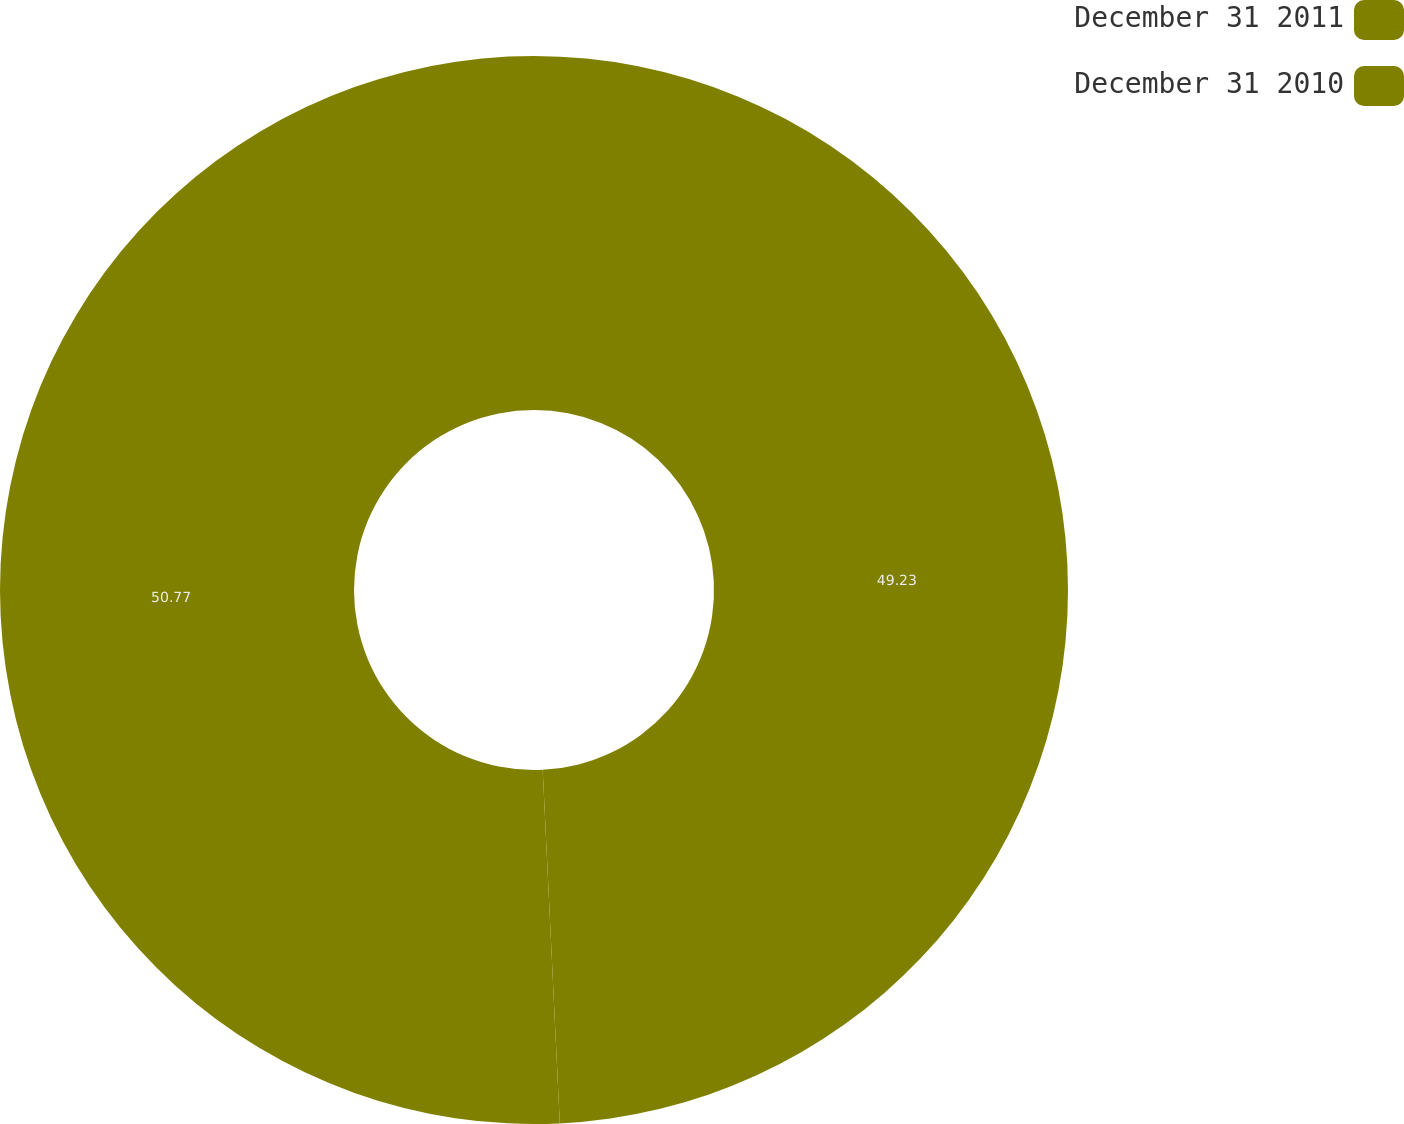Convert chart to OTSL. <chart><loc_0><loc_0><loc_500><loc_500><pie_chart><fcel>December 31 2011<fcel>December 31 2010<nl><fcel>49.23%<fcel>50.77%<nl></chart> 